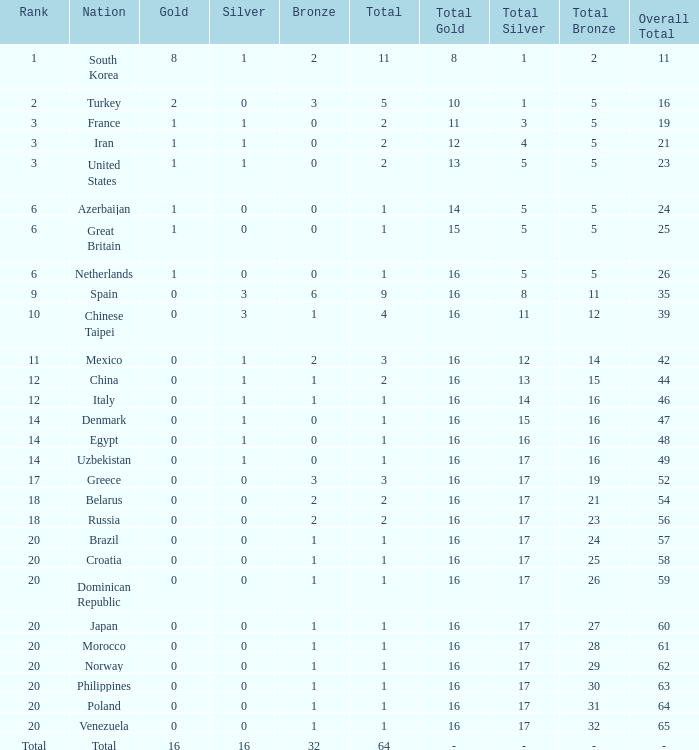How many total silvers does Russia have? 1.0. 